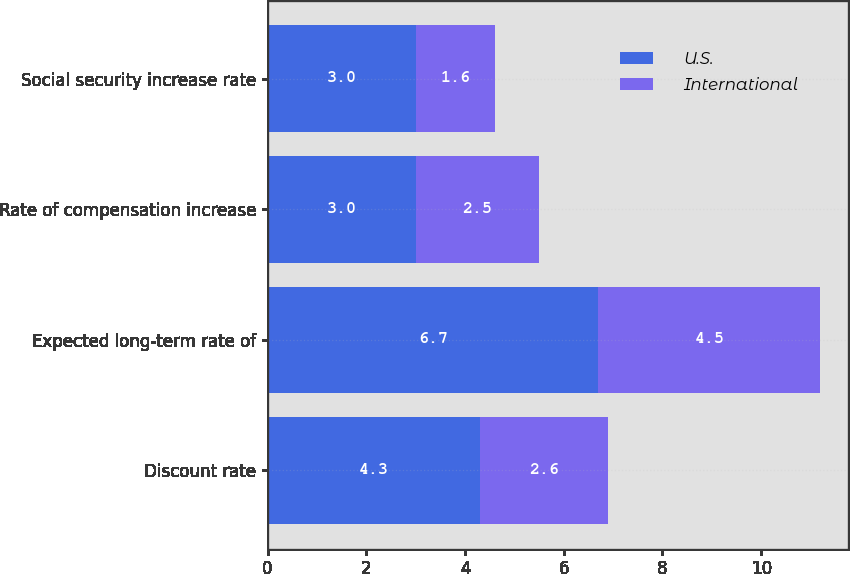Convert chart to OTSL. <chart><loc_0><loc_0><loc_500><loc_500><stacked_bar_chart><ecel><fcel>Discount rate<fcel>Expected long-term rate of<fcel>Rate of compensation increase<fcel>Social security increase rate<nl><fcel>U.S.<fcel>4.3<fcel>6.7<fcel>3<fcel>3<nl><fcel>International<fcel>2.6<fcel>4.5<fcel>2.5<fcel>1.6<nl></chart> 